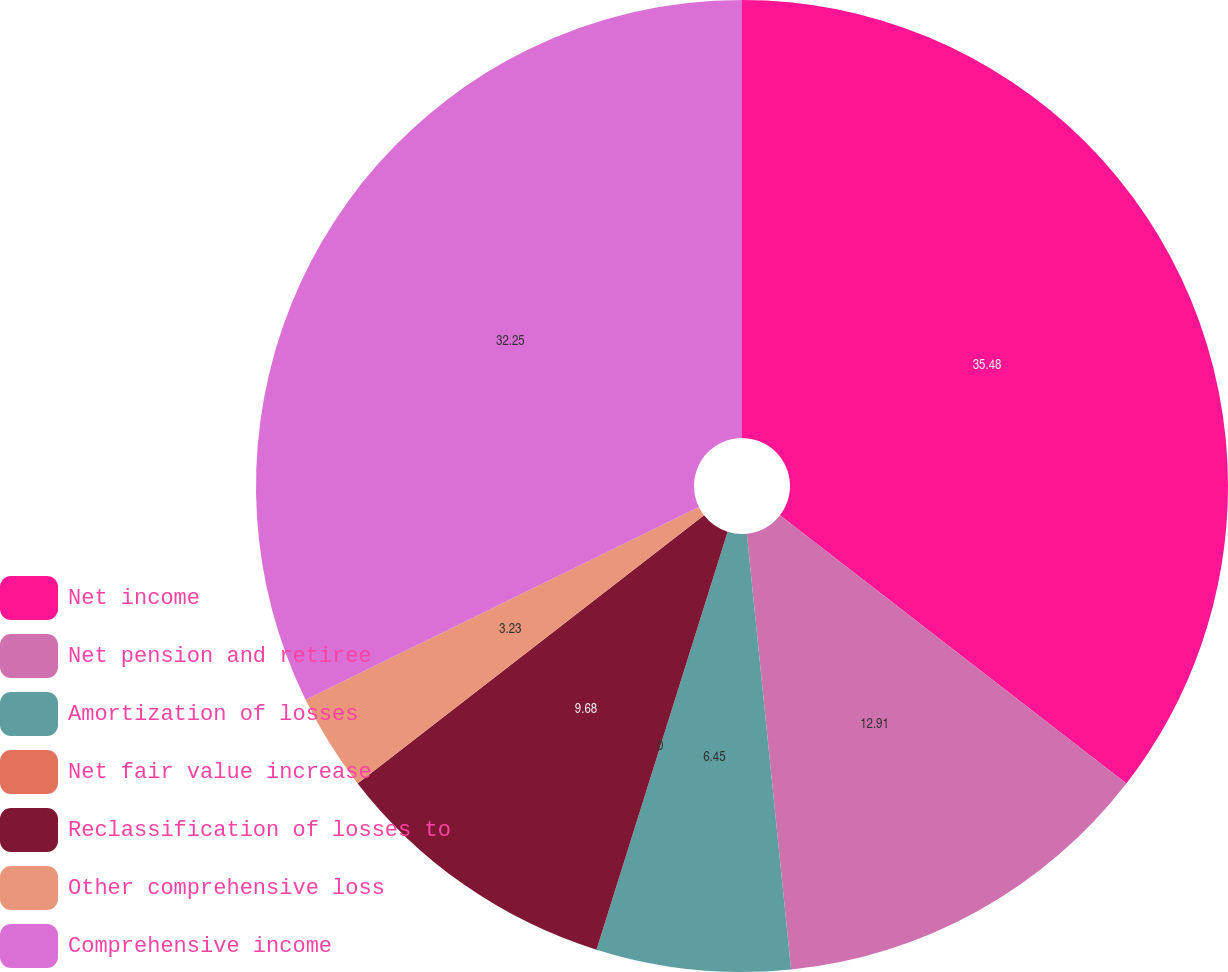Convert chart. <chart><loc_0><loc_0><loc_500><loc_500><pie_chart><fcel>Net income<fcel>Net pension and retiree<fcel>Amortization of losses<fcel>Net fair value increase<fcel>Reclassification of losses to<fcel>Other comprehensive loss<fcel>Comprehensive income<nl><fcel>35.48%<fcel>12.91%<fcel>6.45%<fcel>0.0%<fcel>9.68%<fcel>3.23%<fcel>32.25%<nl></chart> 